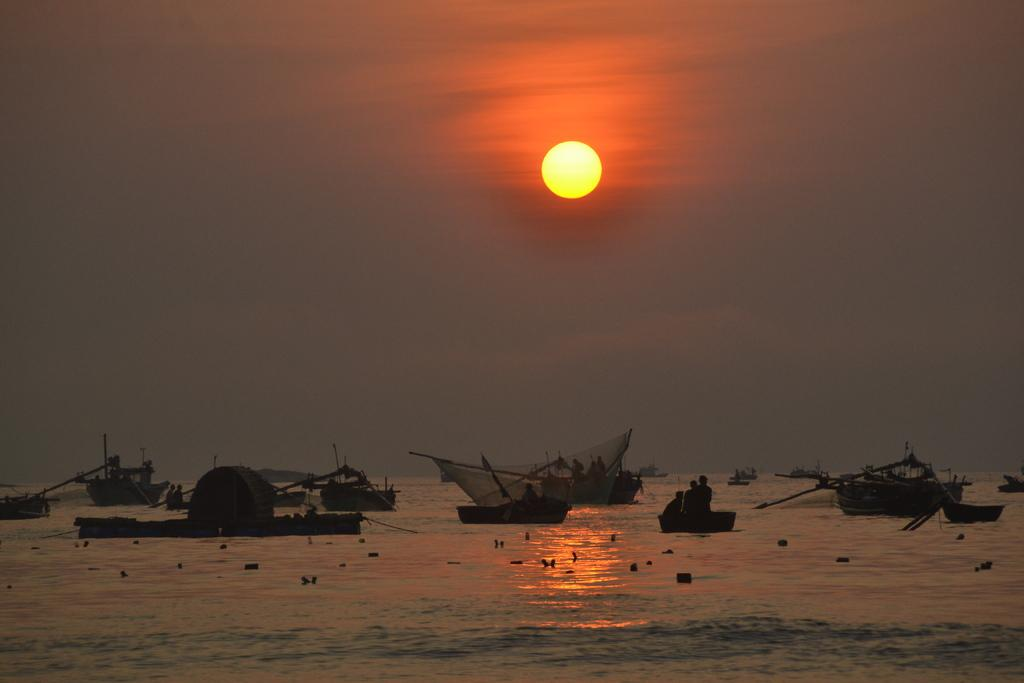What are the people in the image doing? The people are in boats in the image. Where are the boats located? The boats are on water in the image. What can be seen in the sky in the background of the image? The sun is visible in the sky in the background of the image. What type of guitar is the carpenter using to teach a class in the image? There is no guitar or carpenter present in the image, nor is there a class being taught. 